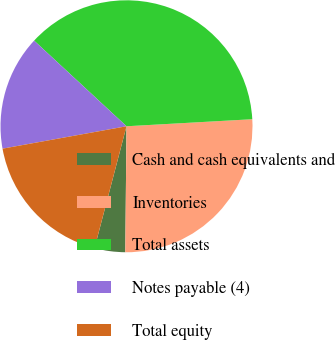Convert chart to OTSL. <chart><loc_0><loc_0><loc_500><loc_500><pie_chart><fcel>Cash and cash equivalents and<fcel>Inventories<fcel>Total assets<fcel>Notes payable (4)<fcel>Total equity<nl><fcel>3.93%<fcel>26.04%<fcel>37.21%<fcel>14.74%<fcel>18.07%<nl></chart> 